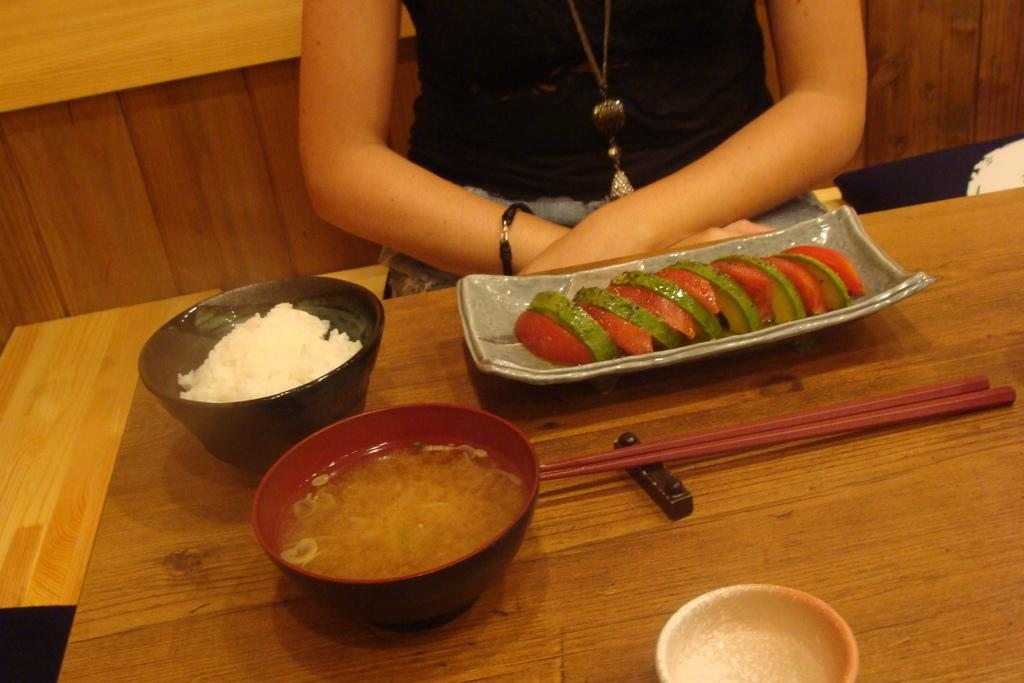What is placed in a bowl in the image? There are eatables placed in a bowl in the image. Where is the bowl located? The bowl is on a table. Can you describe anything about the background of the image? There is a woman wearing a black dress in the background of the image. What type of plantation can be seen in the image? There is no plantation present in the image. 